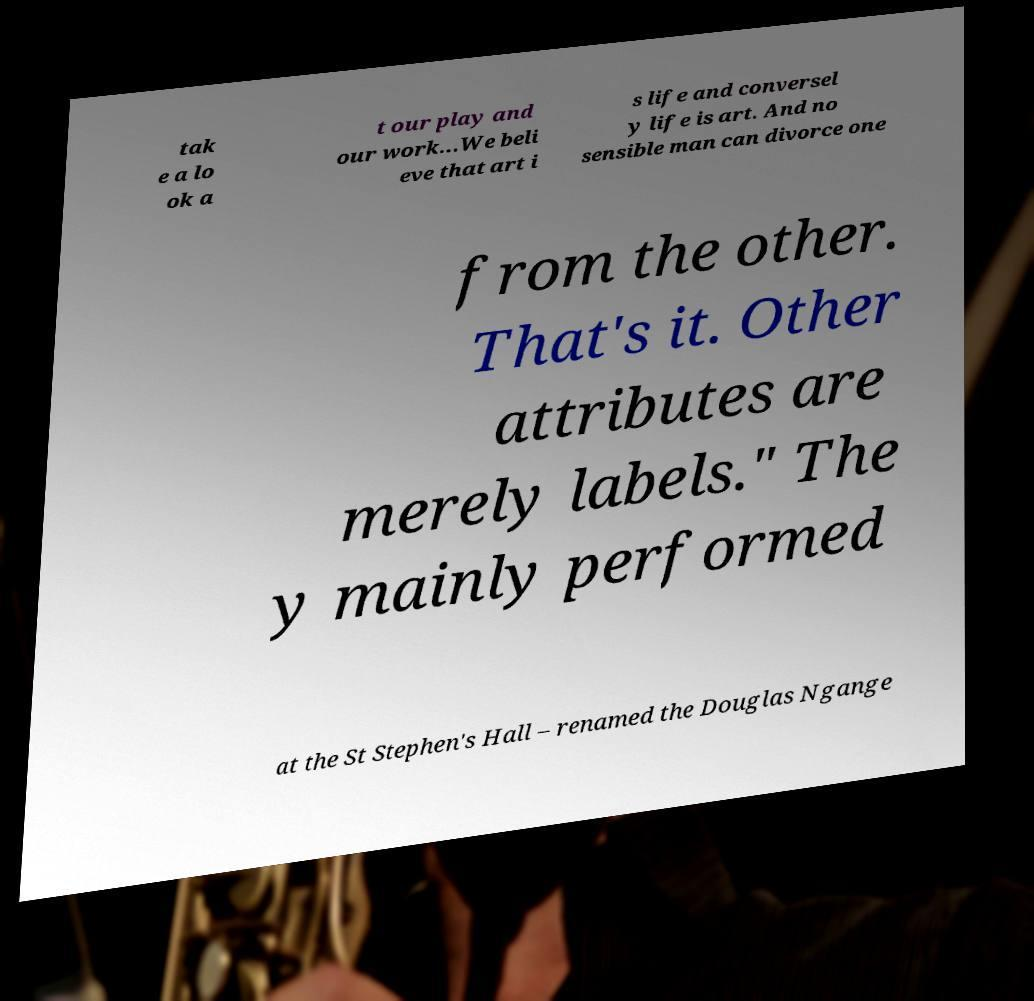Could you assist in decoding the text presented in this image and type it out clearly? tak e a lo ok a t our play and our work...We beli eve that art i s life and conversel y life is art. And no sensible man can divorce one from the other. That's it. Other attributes are merely labels." The y mainly performed at the St Stephen's Hall – renamed the Douglas Ngange 